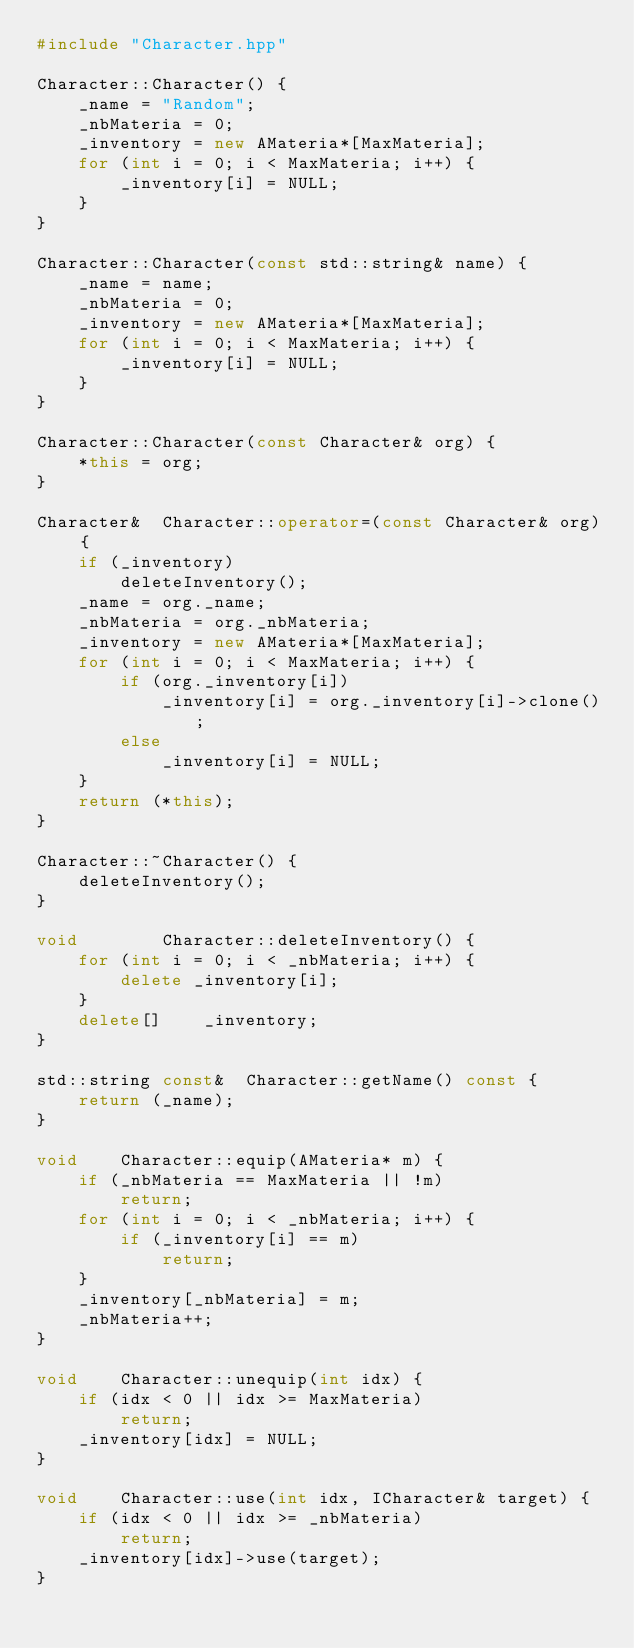Convert code to text. <code><loc_0><loc_0><loc_500><loc_500><_C++_>#include "Character.hpp"

Character::Character() {
	_name = "Random";
	_nbMateria = 0;
	_inventory = new AMateria*[MaxMateria];
	for (int i = 0; i < MaxMateria; i++) {
		_inventory[i] = NULL;
	}
}

Character::Character(const std::string& name) {
	_name = name;
	_nbMateria = 0;
	_inventory = new AMateria*[MaxMateria];
	for (int i = 0; i < MaxMateria; i++) {
		_inventory[i] = NULL;
	}
}

Character::Character(const Character& org) {
	*this = org;
}

Character&	Character::operator=(const Character& org) {
	if (_inventory)
		deleteInventory();
	_name = org._name;
	_nbMateria = org._nbMateria;
	_inventory = new AMateria*[MaxMateria];
	for (int i = 0; i < MaxMateria; i++) {
		if (org._inventory[i])
			_inventory[i] = org._inventory[i]->clone();
		else
			_inventory[i] = NULL;
	}
	return (*this);
}

Character::~Character() {
	deleteInventory();
}

void		Character::deleteInventory() {
	for (int i = 0; i < _nbMateria; i++) {
		delete _inventory[i];
	}
	delete[]	_inventory;
}

std::string const&	Character::getName() const {
	return (_name);
}

void	Character::equip(AMateria* m) {
	if (_nbMateria == MaxMateria || !m)
		return;
	for (int i = 0; i < _nbMateria; i++) {
		if (_inventory[i] == m)
			return;
	}
	_inventory[_nbMateria] = m;
	_nbMateria++;
}

void	Character::unequip(int idx) {
	if (idx < 0 || idx >= MaxMateria)
		return;
	_inventory[idx] = NULL;
}

void	Character::use(int idx, ICharacter& target) {
	if (idx < 0 || idx >= _nbMateria)
		return;
	_inventory[idx]->use(target);
}</code> 